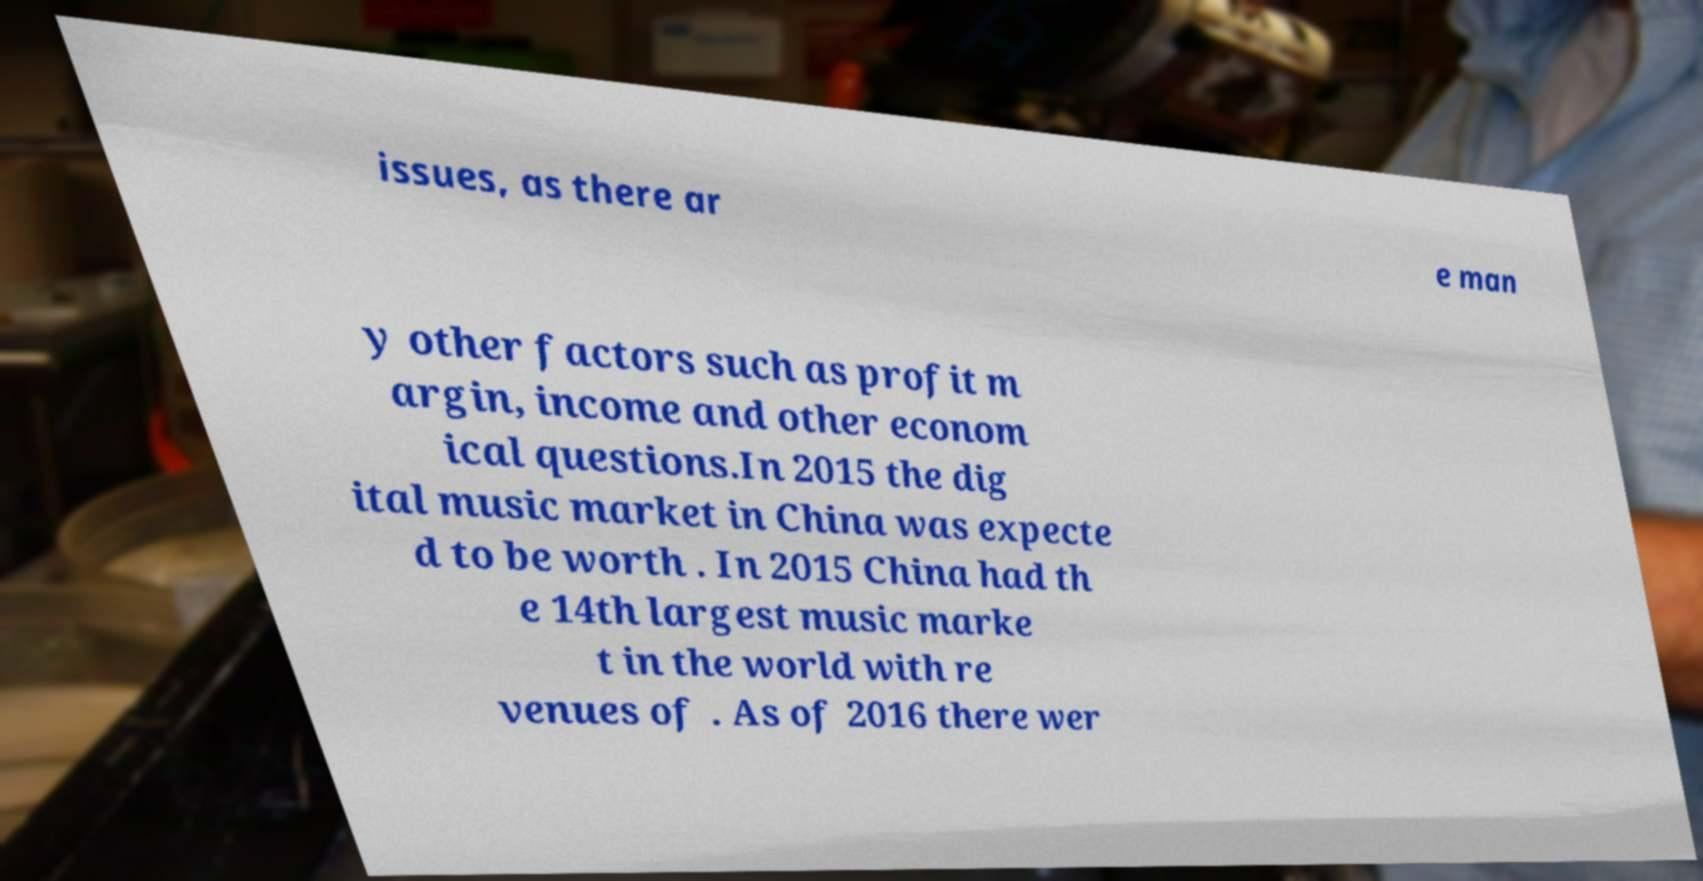I need the written content from this picture converted into text. Can you do that? issues, as there ar e man y other factors such as profit m argin, income and other econom ical questions.In 2015 the dig ital music market in China was expecte d to be worth . In 2015 China had th e 14th largest music marke t in the world with re venues of . As of 2016 there wer 